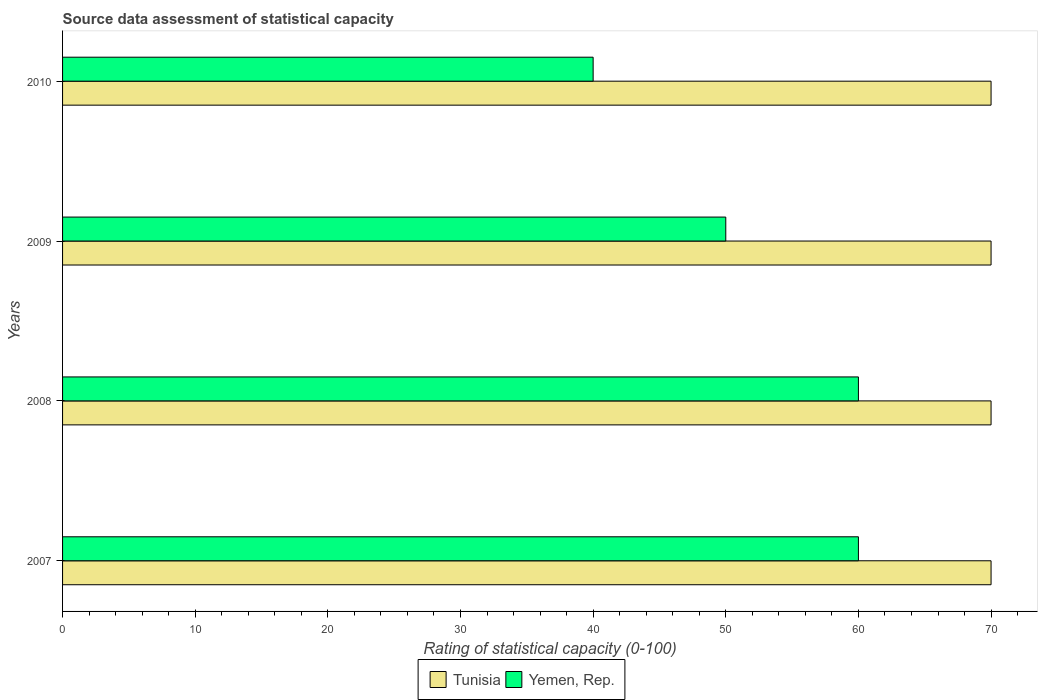How many groups of bars are there?
Your response must be concise. 4. How many bars are there on the 1st tick from the bottom?
Provide a short and direct response. 2. What is the label of the 4th group of bars from the top?
Your answer should be compact. 2007. In how many cases, is the number of bars for a given year not equal to the number of legend labels?
Offer a very short reply. 0. What is the rating of statistical capacity in Tunisia in 2010?
Make the answer very short. 70. Across all years, what is the maximum rating of statistical capacity in Yemen, Rep.?
Make the answer very short. 60. Across all years, what is the minimum rating of statistical capacity in Tunisia?
Offer a very short reply. 70. In which year was the rating of statistical capacity in Tunisia maximum?
Ensure brevity in your answer.  2007. In which year was the rating of statistical capacity in Tunisia minimum?
Keep it short and to the point. 2007. What is the total rating of statistical capacity in Tunisia in the graph?
Give a very brief answer. 280. What is the difference between the rating of statistical capacity in Yemen, Rep. in 2010 and the rating of statistical capacity in Tunisia in 2008?
Give a very brief answer. -30. What is the average rating of statistical capacity in Yemen, Rep. per year?
Offer a very short reply. 52.5. In the year 2007, what is the difference between the rating of statistical capacity in Yemen, Rep. and rating of statistical capacity in Tunisia?
Offer a very short reply. -10. In how many years, is the rating of statistical capacity in Tunisia greater than 52 ?
Your response must be concise. 4. What is the difference between the highest and the second highest rating of statistical capacity in Yemen, Rep.?
Your response must be concise. 0. Is the sum of the rating of statistical capacity in Tunisia in 2007 and 2009 greater than the maximum rating of statistical capacity in Yemen, Rep. across all years?
Your answer should be compact. Yes. What does the 2nd bar from the top in 2008 represents?
Your response must be concise. Tunisia. What does the 2nd bar from the bottom in 2007 represents?
Keep it short and to the point. Yemen, Rep. How many bars are there?
Provide a short and direct response. 8. How many years are there in the graph?
Your response must be concise. 4. Does the graph contain any zero values?
Provide a succinct answer. No. Does the graph contain grids?
Make the answer very short. No. How many legend labels are there?
Provide a short and direct response. 2. How are the legend labels stacked?
Give a very brief answer. Horizontal. What is the title of the graph?
Ensure brevity in your answer.  Source data assessment of statistical capacity. What is the label or title of the X-axis?
Give a very brief answer. Rating of statistical capacity (0-100). What is the label or title of the Y-axis?
Ensure brevity in your answer.  Years. What is the Rating of statistical capacity (0-100) of Tunisia in 2007?
Your response must be concise. 70. What is the Rating of statistical capacity (0-100) in Tunisia in 2008?
Your answer should be compact. 70. What is the Rating of statistical capacity (0-100) of Yemen, Rep. in 2008?
Ensure brevity in your answer.  60. What is the Rating of statistical capacity (0-100) in Tunisia in 2010?
Your answer should be compact. 70. What is the Rating of statistical capacity (0-100) of Yemen, Rep. in 2010?
Your answer should be very brief. 40. Across all years, what is the maximum Rating of statistical capacity (0-100) in Tunisia?
Your answer should be very brief. 70. Across all years, what is the maximum Rating of statistical capacity (0-100) of Yemen, Rep.?
Your answer should be compact. 60. Across all years, what is the minimum Rating of statistical capacity (0-100) of Yemen, Rep.?
Provide a succinct answer. 40. What is the total Rating of statistical capacity (0-100) in Tunisia in the graph?
Your response must be concise. 280. What is the total Rating of statistical capacity (0-100) in Yemen, Rep. in the graph?
Your response must be concise. 210. What is the difference between the Rating of statistical capacity (0-100) in Tunisia in 2007 and that in 2008?
Ensure brevity in your answer.  0. What is the difference between the Rating of statistical capacity (0-100) of Yemen, Rep. in 2007 and that in 2009?
Your answer should be very brief. 10. What is the difference between the Rating of statistical capacity (0-100) in Tunisia in 2007 and that in 2010?
Offer a very short reply. 0. What is the difference between the Rating of statistical capacity (0-100) of Yemen, Rep. in 2007 and that in 2010?
Provide a short and direct response. 20. What is the difference between the Rating of statistical capacity (0-100) in Tunisia in 2007 and the Rating of statistical capacity (0-100) in Yemen, Rep. in 2009?
Your response must be concise. 20. What is the difference between the Rating of statistical capacity (0-100) in Tunisia in 2009 and the Rating of statistical capacity (0-100) in Yemen, Rep. in 2010?
Your response must be concise. 30. What is the average Rating of statistical capacity (0-100) of Yemen, Rep. per year?
Your response must be concise. 52.5. What is the ratio of the Rating of statistical capacity (0-100) in Yemen, Rep. in 2007 to that in 2009?
Offer a terse response. 1.2. What is the ratio of the Rating of statistical capacity (0-100) in Tunisia in 2007 to that in 2010?
Offer a very short reply. 1. What is the ratio of the Rating of statistical capacity (0-100) of Yemen, Rep. in 2007 to that in 2010?
Provide a succinct answer. 1.5. What is the ratio of the Rating of statistical capacity (0-100) in Yemen, Rep. in 2008 to that in 2009?
Your answer should be very brief. 1.2. What is the ratio of the Rating of statistical capacity (0-100) of Tunisia in 2008 to that in 2010?
Your answer should be compact. 1. What is the ratio of the Rating of statistical capacity (0-100) of Yemen, Rep. in 2008 to that in 2010?
Provide a succinct answer. 1.5. What is the ratio of the Rating of statistical capacity (0-100) in Yemen, Rep. in 2009 to that in 2010?
Your response must be concise. 1.25. 